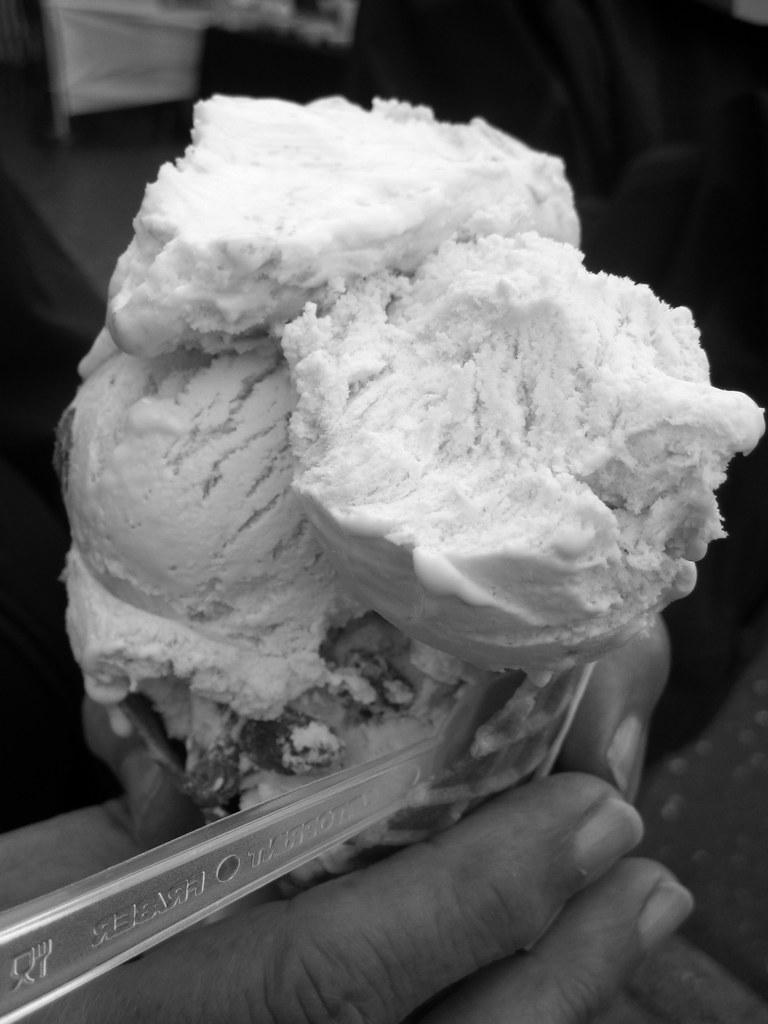Who or what is the main subject in the image? There is a person in the image. What is the person holding in the image? The person is holding ice cream. Can you describe any objects near the person? There are a few objects beside the person. What type of bead is the person wearing in the image? There is no bead visible in the image. How many cents does the person owe for the ice cream in the image? There is no indication of a price or currency in the image. 